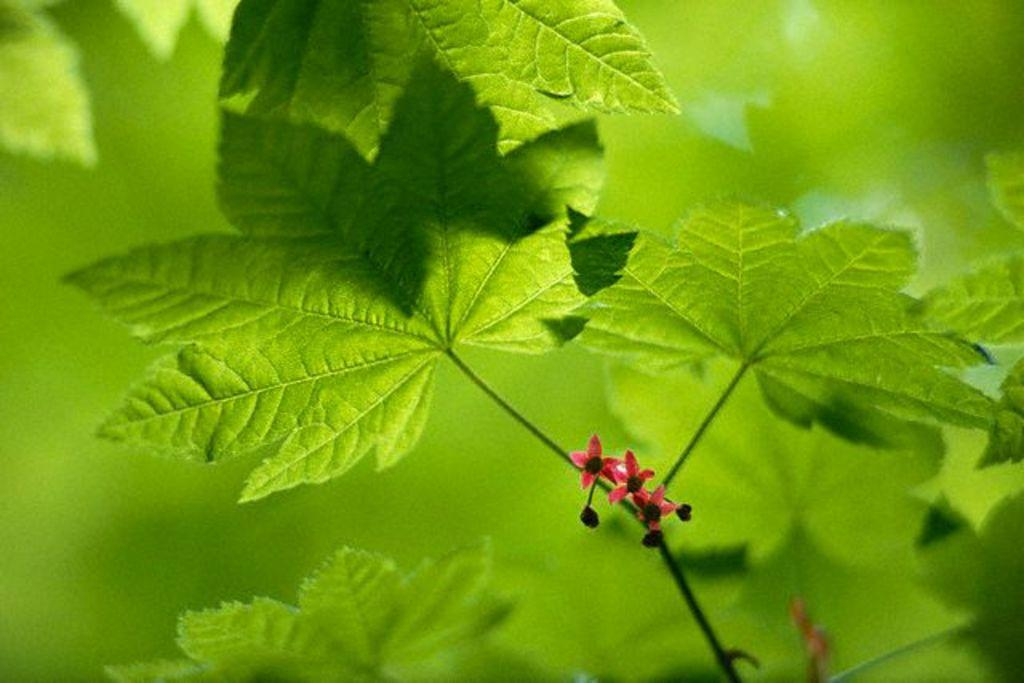What is the main subject of the image? There is a plant in the image. What can be observed about the plant's appearance? The plant has small flowers. How would you describe the background of the image? The background of the image is blurry. How does the turkey look after the plant in the image? There is no turkey present in the image, so it cannot be determined how it would look or interact with the plant. 